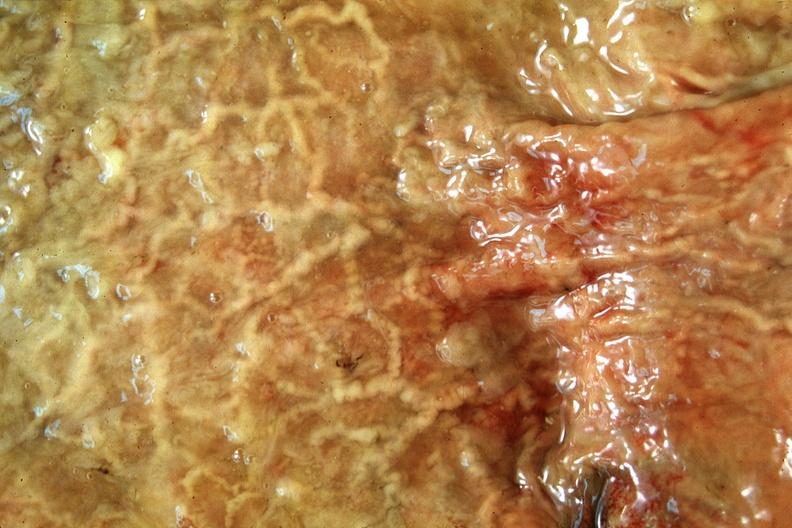where does this belong to?
Answer the question using a single word or phrase. Gastrointestinal system 